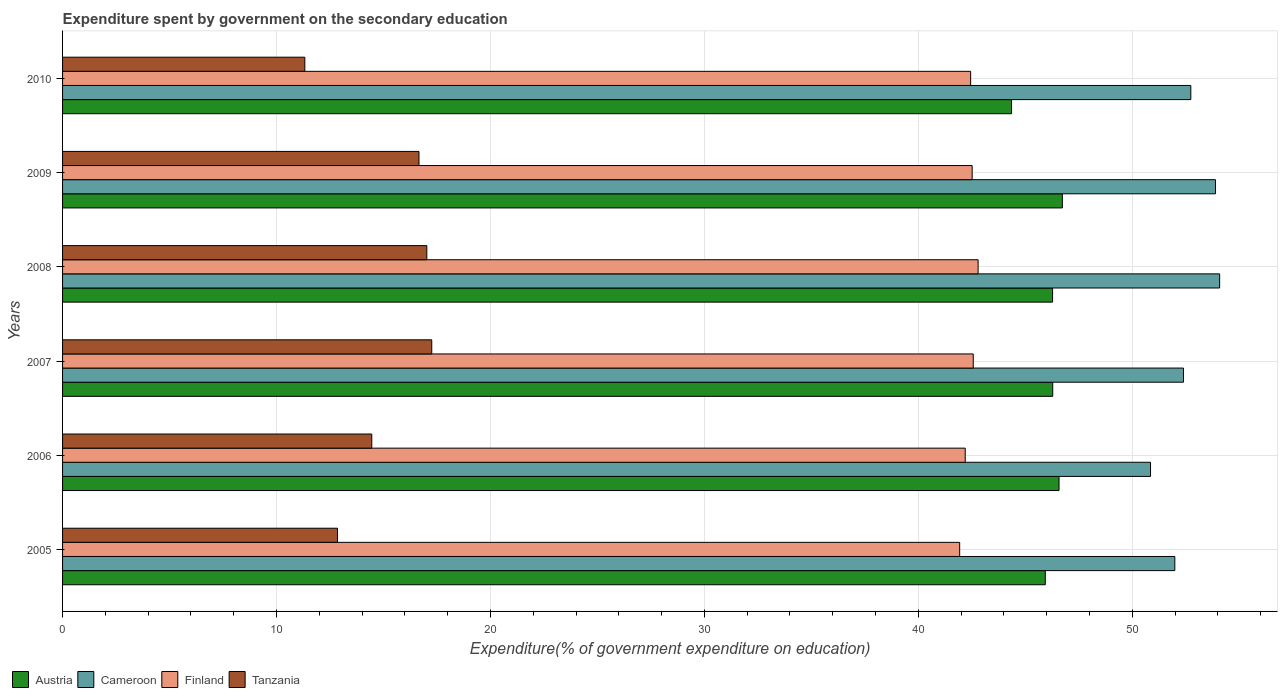How many groups of bars are there?
Give a very brief answer. 6. Are the number of bars per tick equal to the number of legend labels?
Your response must be concise. Yes. Are the number of bars on each tick of the Y-axis equal?
Give a very brief answer. Yes. How many bars are there on the 5th tick from the bottom?
Offer a terse response. 4. What is the label of the 6th group of bars from the top?
Offer a terse response. 2005. In how many cases, is the number of bars for a given year not equal to the number of legend labels?
Offer a terse response. 0. What is the expenditure spent by government on the secondary education in Finland in 2009?
Give a very brief answer. 42.52. Across all years, what is the maximum expenditure spent by government on the secondary education in Finland?
Make the answer very short. 42.8. Across all years, what is the minimum expenditure spent by government on the secondary education in Austria?
Give a very brief answer. 44.36. In which year was the expenditure spent by government on the secondary education in Finland maximum?
Offer a terse response. 2008. What is the total expenditure spent by government on the secondary education in Finland in the graph?
Ensure brevity in your answer.  254.46. What is the difference between the expenditure spent by government on the secondary education in Cameroon in 2008 and that in 2009?
Your answer should be compact. 0.19. What is the difference between the expenditure spent by government on the secondary education in Finland in 2006 and the expenditure spent by government on the secondary education in Cameroon in 2007?
Keep it short and to the point. -10.2. What is the average expenditure spent by government on the secondary education in Cameroon per year?
Make the answer very short. 52.66. In the year 2006, what is the difference between the expenditure spent by government on the secondary education in Tanzania and expenditure spent by government on the secondary education in Finland?
Your response must be concise. -27.74. What is the ratio of the expenditure spent by government on the secondary education in Cameroon in 2008 to that in 2010?
Offer a very short reply. 1.03. Is the expenditure spent by government on the secondary education in Cameroon in 2006 less than that in 2010?
Offer a very short reply. Yes. What is the difference between the highest and the second highest expenditure spent by government on the secondary education in Tanzania?
Provide a succinct answer. 0.23. What is the difference between the highest and the lowest expenditure spent by government on the secondary education in Austria?
Ensure brevity in your answer.  2.37. In how many years, is the expenditure spent by government on the secondary education in Cameroon greater than the average expenditure spent by government on the secondary education in Cameroon taken over all years?
Keep it short and to the point. 3. What does the 1st bar from the top in 2005 represents?
Ensure brevity in your answer.  Tanzania. What does the 4th bar from the bottom in 2009 represents?
Ensure brevity in your answer.  Tanzania. Are all the bars in the graph horizontal?
Make the answer very short. Yes. How many years are there in the graph?
Your answer should be very brief. 6. What is the difference between two consecutive major ticks on the X-axis?
Provide a short and direct response. 10. Does the graph contain any zero values?
Offer a very short reply. No. Does the graph contain grids?
Your response must be concise. Yes. Where does the legend appear in the graph?
Keep it short and to the point. Bottom left. How are the legend labels stacked?
Provide a succinct answer. Horizontal. What is the title of the graph?
Ensure brevity in your answer.  Expenditure spent by government on the secondary education. What is the label or title of the X-axis?
Keep it short and to the point. Expenditure(% of government expenditure on education). What is the label or title of the Y-axis?
Provide a short and direct response. Years. What is the Expenditure(% of government expenditure on education) of Austria in 2005?
Your response must be concise. 45.94. What is the Expenditure(% of government expenditure on education) of Cameroon in 2005?
Offer a very short reply. 51.99. What is the Expenditure(% of government expenditure on education) in Finland in 2005?
Offer a very short reply. 41.93. What is the Expenditure(% of government expenditure on education) of Tanzania in 2005?
Make the answer very short. 12.85. What is the Expenditure(% of government expenditure on education) in Austria in 2006?
Offer a very short reply. 46.58. What is the Expenditure(% of government expenditure on education) in Cameroon in 2006?
Give a very brief answer. 50.86. What is the Expenditure(% of government expenditure on education) in Finland in 2006?
Your answer should be compact. 42.19. What is the Expenditure(% of government expenditure on education) of Tanzania in 2006?
Offer a very short reply. 14.45. What is the Expenditure(% of government expenditure on education) of Austria in 2007?
Make the answer very short. 46.28. What is the Expenditure(% of government expenditure on education) of Cameroon in 2007?
Your answer should be very brief. 52.4. What is the Expenditure(% of government expenditure on education) of Finland in 2007?
Keep it short and to the point. 42.57. What is the Expenditure(% of government expenditure on education) in Tanzania in 2007?
Provide a short and direct response. 17.26. What is the Expenditure(% of government expenditure on education) in Austria in 2008?
Provide a short and direct response. 46.28. What is the Expenditure(% of government expenditure on education) of Cameroon in 2008?
Your answer should be very brief. 54.09. What is the Expenditure(% of government expenditure on education) in Finland in 2008?
Your answer should be compact. 42.8. What is the Expenditure(% of government expenditure on education) in Tanzania in 2008?
Your answer should be compact. 17.03. What is the Expenditure(% of government expenditure on education) of Austria in 2009?
Make the answer very short. 46.73. What is the Expenditure(% of government expenditure on education) of Cameroon in 2009?
Provide a succinct answer. 53.89. What is the Expenditure(% of government expenditure on education) of Finland in 2009?
Keep it short and to the point. 42.52. What is the Expenditure(% of government expenditure on education) of Tanzania in 2009?
Your answer should be very brief. 16.66. What is the Expenditure(% of government expenditure on education) in Austria in 2010?
Give a very brief answer. 44.36. What is the Expenditure(% of government expenditure on education) of Cameroon in 2010?
Ensure brevity in your answer.  52.74. What is the Expenditure(% of government expenditure on education) in Finland in 2010?
Keep it short and to the point. 42.45. What is the Expenditure(% of government expenditure on education) of Tanzania in 2010?
Make the answer very short. 11.32. Across all years, what is the maximum Expenditure(% of government expenditure on education) of Austria?
Your response must be concise. 46.73. Across all years, what is the maximum Expenditure(% of government expenditure on education) in Cameroon?
Your response must be concise. 54.09. Across all years, what is the maximum Expenditure(% of government expenditure on education) of Finland?
Offer a terse response. 42.8. Across all years, what is the maximum Expenditure(% of government expenditure on education) in Tanzania?
Your response must be concise. 17.26. Across all years, what is the minimum Expenditure(% of government expenditure on education) of Austria?
Your answer should be very brief. 44.36. Across all years, what is the minimum Expenditure(% of government expenditure on education) in Cameroon?
Your answer should be very brief. 50.86. Across all years, what is the minimum Expenditure(% of government expenditure on education) of Finland?
Make the answer very short. 41.93. Across all years, what is the minimum Expenditure(% of government expenditure on education) of Tanzania?
Give a very brief answer. 11.32. What is the total Expenditure(% of government expenditure on education) in Austria in the graph?
Make the answer very short. 276.17. What is the total Expenditure(% of government expenditure on education) of Cameroon in the graph?
Give a very brief answer. 315.96. What is the total Expenditure(% of government expenditure on education) in Finland in the graph?
Keep it short and to the point. 254.46. What is the total Expenditure(% of government expenditure on education) of Tanzania in the graph?
Make the answer very short. 89.57. What is the difference between the Expenditure(% of government expenditure on education) of Austria in 2005 and that in 2006?
Your answer should be compact. -0.64. What is the difference between the Expenditure(% of government expenditure on education) in Cameroon in 2005 and that in 2006?
Give a very brief answer. 1.14. What is the difference between the Expenditure(% of government expenditure on education) in Finland in 2005 and that in 2006?
Provide a succinct answer. -0.26. What is the difference between the Expenditure(% of government expenditure on education) in Tanzania in 2005 and that in 2006?
Your answer should be compact. -1.6. What is the difference between the Expenditure(% of government expenditure on education) in Austria in 2005 and that in 2007?
Offer a very short reply. -0.35. What is the difference between the Expenditure(% of government expenditure on education) of Cameroon in 2005 and that in 2007?
Your response must be concise. -0.4. What is the difference between the Expenditure(% of government expenditure on education) of Finland in 2005 and that in 2007?
Provide a succinct answer. -0.63. What is the difference between the Expenditure(% of government expenditure on education) in Tanzania in 2005 and that in 2007?
Your answer should be very brief. -4.41. What is the difference between the Expenditure(% of government expenditure on education) of Austria in 2005 and that in 2008?
Offer a very short reply. -0.34. What is the difference between the Expenditure(% of government expenditure on education) in Cameroon in 2005 and that in 2008?
Offer a very short reply. -2.09. What is the difference between the Expenditure(% of government expenditure on education) in Finland in 2005 and that in 2008?
Offer a very short reply. -0.86. What is the difference between the Expenditure(% of government expenditure on education) of Tanzania in 2005 and that in 2008?
Your response must be concise. -4.17. What is the difference between the Expenditure(% of government expenditure on education) in Austria in 2005 and that in 2009?
Make the answer very short. -0.8. What is the difference between the Expenditure(% of government expenditure on education) of Cameroon in 2005 and that in 2009?
Ensure brevity in your answer.  -1.9. What is the difference between the Expenditure(% of government expenditure on education) of Finland in 2005 and that in 2009?
Make the answer very short. -0.58. What is the difference between the Expenditure(% of government expenditure on education) of Tanzania in 2005 and that in 2009?
Provide a short and direct response. -3.81. What is the difference between the Expenditure(% of government expenditure on education) in Austria in 2005 and that in 2010?
Keep it short and to the point. 1.58. What is the difference between the Expenditure(% of government expenditure on education) in Cameroon in 2005 and that in 2010?
Ensure brevity in your answer.  -0.75. What is the difference between the Expenditure(% of government expenditure on education) of Finland in 2005 and that in 2010?
Give a very brief answer. -0.51. What is the difference between the Expenditure(% of government expenditure on education) in Tanzania in 2005 and that in 2010?
Your answer should be very brief. 1.53. What is the difference between the Expenditure(% of government expenditure on education) of Austria in 2006 and that in 2007?
Give a very brief answer. 0.29. What is the difference between the Expenditure(% of government expenditure on education) in Cameroon in 2006 and that in 2007?
Provide a short and direct response. -1.54. What is the difference between the Expenditure(% of government expenditure on education) in Finland in 2006 and that in 2007?
Keep it short and to the point. -0.38. What is the difference between the Expenditure(% of government expenditure on education) of Tanzania in 2006 and that in 2007?
Offer a very short reply. -2.8. What is the difference between the Expenditure(% of government expenditure on education) of Austria in 2006 and that in 2008?
Your response must be concise. 0.3. What is the difference between the Expenditure(% of government expenditure on education) in Cameroon in 2006 and that in 2008?
Provide a short and direct response. -3.23. What is the difference between the Expenditure(% of government expenditure on education) of Finland in 2006 and that in 2008?
Make the answer very short. -0.6. What is the difference between the Expenditure(% of government expenditure on education) of Tanzania in 2006 and that in 2008?
Provide a succinct answer. -2.57. What is the difference between the Expenditure(% of government expenditure on education) of Austria in 2006 and that in 2009?
Provide a short and direct response. -0.15. What is the difference between the Expenditure(% of government expenditure on education) in Cameroon in 2006 and that in 2009?
Make the answer very short. -3.04. What is the difference between the Expenditure(% of government expenditure on education) of Finland in 2006 and that in 2009?
Offer a terse response. -0.32. What is the difference between the Expenditure(% of government expenditure on education) of Tanzania in 2006 and that in 2009?
Give a very brief answer. -2.21. What is the difference between the Expenditure(% of government expenditure on education) in Austria in 2006 and that in 2010?
Ensure brevity in your answer.  2.22. What is the difference between the Expenditure(% of government expenditure on education) of Cameroon in 2006 and that in 2010?
Your answer should be very brief. -1.88. What is the difference between the Expenditure(% of government expenditure on education) of Finland in 2006 and that in 2010?
Your answer should be compact. -0.25. What is the difference between the Expenditure(% of government expenditure on education) in Tanzania in 2006 and that in 2010?
Provide a short and direct response. 3.13. What is the difference between the Expenditure(% of government expenditure on education) in Austria in 2007 and that in 2008?
Make the answer very short. 0.01. What is the difference between the Expenditure(% of government expenditure on education) of Cameroon in 2007 and that in 2008?
Make the answer very short. -1.69. What is the difference between the Expenditure(% of government expenditure on education) of Finland in 2007 and that in 2008?
Make the answer very short. -0.23. What is the difference between the Expenditure(% of government expenditure on education) in Tanzania in 2007 and that in 2008?
Provide a succinct answer. 0.23. What is the difference between the Expenditure(% of government expenditure on education) of Austria in 2007 and that in 2009?
Offer a very short reply. -0.45. What is the difference between the Expenditure(% of government expenditure on education) of Cameroon in 2007 and that in 2009?
Your response must be concise. -1.5. What is the difference between the Expenditure(% of government expenditure on education) in Finland in 2007 and that in 2009?
Offer a terse response. 0.05. What is the difference between the Expenditure(% of government expenditure on education) of Tanzania in 2007 and that in 2009?
Provide a succinct answer. 0.6. What is the difference between the Expenditure(% of government expenditure on education) of Austria in 2007 and that in 2010?
Your answer should be very brief. 1.92. What is the difference between the Expenditure(% of government expenditure on education) of Cameroon in 2007 and that in 2010?
Make the answer very short. -0.34. What is the difference between the Expenditure(% of government expenditure on education) of Finland in 2007 and that in 2010?
Keep it short and to the point. 0.12. What is the difference between the Expenditure(% of government expenditure on education) in Tanzania in 2007 and that in 2010?
Provide a succinct answer. 5.93. What is the difference between the Expenditure(% of government expenditure on education) of Austria in 2008 and that in 2009?
Give a very brief answer. -0.46. What is the difference between the Expenditure(% of government expenditure on education) in Cameroon in 2008 and that in 2009?
Give a very brief answer. 0.19. What is the difference between the Expenditure(% of government expenditure on education) of Finland in 2008 and that in 2009?
Provide a short and direct response. 0.28. What is the difference between the Expenditure(% of government expenditure on education) of Tanzania in 2008 and that in 2009?
Offer a very short reply. 0.37. What is the difference between the Expenditure(% of government expenditure on education) in Austria in 2008 and that in 2010?
Keep it short and to the point. 1.92. What is the difference between the Expenditure(% of government expenditure on education) of Cameroon in 2008 and that in 2010?
Your response must be concise. 1.35. What is the difference between the Expenditure(% of government expenditure on education) of Finland in 2008 and that in 2010?
Offer a very short reply. 0.35. What is the difference between the Expenditure(% of government expenditure on education) in Tanzania in 2008 and that in 2010?
Your answer should be compact. 5.7. What is the difference between the Expenditure(% of government expenditure on education) of Austria in 2009 and that in 2010?
Provide a short and direct response. 2.37. What is the difference between the Expenditure(% of government expenditure on education) in Cameroon in 2009 and that in 2010?
Make the answer very short. 1.15. What is the difference between the Expenditure(% of government expenditure on education) in Finland in 2009 and that in 2010?
Your response must be concise. 0.07. What is the difference between the Expenditure(% of government expenditure on education) in Tanzania in 2009 and that in 2010?
Offer a terse response. 5.34. What is the difference between the Expenditure(% of government expenditure on education) of Austria in 2005 and the Expenditure(% of government expenditure on education) of Cameroon in 2006?
Your answer should be compact. -4.92. What is the difference between the Expenditure(% of government expenditure on education) in Austria in 2005 and the Expenditure(% of government expenditure on education) in Finland in 2006?
Keep it short and to the point. 3.74. What is the difference between the Expenditure(% of government expenditure on education) of Austria in 2005 and the Expenditure(% of government expenditure on education) of Tanzania in 2006?
Provide a succinct answer. 31.48. What is the difference between the Expenditure(% of government expenditure on education) in Cameroon in 2005 and the Expenditure(% of government expenditure on education) in Finland in 2006?
Ensure brevity in your answer.  9.8. What is the difference between the Expenditure(% of government expenditure on education) of Cameroon in 2005 and the Expenditure(% of government expenditure on education) of Tanzania in 2006?
Ensure brevity in your answer.  37.54. What is the difference between the Expenditure(% of government expenditure on education) of Finland in 2005 and the Expenditure(% of government expenditure on education) of Tanzania in 2006?
Ensure brevity in your answer.  27.48. What is the difference between the Expenditure(% of government expenditure on education) in Austria in 2005 and the Expenditure(% of government expenditure on education) in Cameroon in 2007?
Keep it short and to the point. -6.46. What is the difference between the Expenditure(% of government expenditure on education) in Austria in 2005 and the Expenditure(% of government expenditure on education) in Finland in 2007?
Offer a very short reply. 3.37. What is the difference between the Expenditure(% of government expenditure on education) of Austria in 2005 and the Expenditure(% of government expenditure on education) of Tanzania in 2007?
Offer a very short reply. 28.68. What is the difference between the Expenditure(% of government expenditure on education) of Cameroon in 2005 and the Expenditure(% of government expenditure on education) of Finland in 2007?
Offer a very short reply. 9.42. What is the difference between the Expenditure(% of government expenditure on education) of Cameroon in 2005 and the Expenditure(% of government expenditure on education) of Tanzania in 2007?
Keep it short and to the point. 34.74. What is the difference between the Expenditure(% of government expenditure on education) in Finland in 2005 and the Expenditure(% of government expenditure on education) in Tanzania in 2007?
Provide a short and direct response. 24.68. What is the difference between the Expenditure(% of government expenditure on education) in Austria in 2005 and the Expenditure(% of government expenditure on education) in Cameroon in 2008?
Your answer should be compact. -8.15. What is the difference between the Expenditure(% of government expenditure on education) in Austria in 2005 and the Expenditure(% of government expenditure on education) in Finland in 2008?
Ensure brevity in your answer.  3.14. What is the difference between the Expenditure(% of government expenditure on education) of Austria in 2005 and the Expenditure(% of government expenditure on education) of Tanzania in 2008?
Your answer should be very brief. 28.91. What is the difference between the Expenditure(% of government expenditure on education) of Cameroon in 2005 and the Expenditure(% of government expenditure on education) of Finland in 2008?
Keep it short and to the point. 9.2. What is the difference between the Expenditure(% of government expenditure on education) in Cameroon in 2005 and the Expenditure(% of government expenditure on education) in Tanzania in 2008?
Offer a very short reply. 34.97. What is the difference between the Expenditure(% of government expenditure on education) of Finland in 2005 and the Expenditure(% of government expenditure on education) of Tanzania in 2008?
Provide a succinct answer. 24.91. What is the difference between the Expenditure(% of government expenditure on education) in Austria in 2005 and the Expenditure(% of government expenditure on education) in Cameroon in 2009?
Provide a succinct answer. -7.95. What is the difference between the Expenditure(% of government expenditure on education) in Austria in 2005 and the Expenditure(% of government expenditure on education) in Finland in 2009?
Ensure brevity in your answer.  3.42. What is the difference between the Expenditure(% of government expenditure on education) in Austria in 2005 and the Expenditure(% of government expenditure on education) in Tanzania in 2009?
Keep it short and to the point. 29.28. What is the difference between the Expenditure(% of government expenditure on education) in Cameroon in 2005 and the Expenditure(% of government expenditure on education) in Finland in 2009?
Your answer should be very brief. 9.47. What is the difference between the Expenditure(% of government expenditure on education) of Cameroon in 2005 and the Expenditure(% of government expenditure on education) of Tanzania in 2009?
Make the answer very short. 35.33. What is the difference between the Expenditure(% of government expenditure on education) of Finland in 2005 and the Expenditure(% of government expenditure on education) of Tanzania in 2009?
Provide a succinct answer. 25.27. What is the difference between the Expenditure(% of government expenditure on education) of Austria in 2005 and the Expenditure(% of government expenditure on education) of Cameroon in 2010?
Your answer should be compact. -6.8. What is the difference between the Expenditure(% of government expenditure on education) of Austria in 2005 and the Expenditure(% of government expenditure on education) of Finland in 2010?
Your answer should be very brief. 3.49. What is the difference between the Expenditure(% of government expenditure on education) of Austria in 2005 and the Expenditure(% of government expenditure on education) of Tanzania in 2010?
Offer a very short reply. 34.61. What is the difference between the Expenditure(% of government expenditure on education) in Cameroon in 2005 and the Expenditure(% of government expenditure on education) in Finland in 2010?
Your answer should be very brief. 9.54. What is the difference between the Expenditure(% of government expenditure on education) of Cameroon in 2005 and the Expenditure(% of government expenditure on education) of Tanzania in 2010?
Provide a short and direct response. 40.67. What is the difference between the Expenditure(% of government expenditure on education) in Finland in 2005 and the Expenditure(% of government expenditure on education) in Tanzania in 2010?
Offer a terse response. 30.61. What is the difference between the Expenditure(% of government expenditure on education) in Austria in 2006 and the Expenditure(% of government expenditure on education) in Cameroon in 2007?
Provide a short and direct response. -5.82. What is the difference between the Expenditure(% of government expenditure on education) of Austria in 2006 and the Expenditure(% of government expenditure on education) of Finland in 2007?
Make the answer very short. 4.01. What is the difference between the Expenditure(% of government expenditure on education) of Austria in 2006 and the Expenditure(% of government expenditure on education) of Tanzania in 2007?
Ensure brevity in your answer.  29.32. What is the difference between the Expenditure(% of government expenditure on education) in Cameroon in 2006 and the Expenditure(% of government expenditure on education) in Finland in 2007?
Ensure brevity in your answer.  8.29. What is the difference between the Expenditure(% of government expenditure on education) in Cameroon in 2006 and the Expenditure(% of government expenditure on education) in Tanzania in 2007?
Offer a terse response. 33.6. What is the difference between the Expenditure(% of government expenditure on education) in Finland in 2006 and the Expenditure(% of government expenditure on education) in Tanzania in 2007?
Offer a terse response. 24.94. What is the difference between the Expenditure(% of government expenditure on education) of Austria in 2006 and the Expenditure(% of government expenditure on education) of Cameroon in 2008?
Offer a very short reply. -7.51. What is the difference between the Expenditure(% of government expenditure on education) in Austria in 2006 and the Expenditure(% of government expenditure on education) in Finland in 2008?
Give a very brief answer. 3.78. What is the difference between the Expenditure(% of government expenditure on education) of Austria in 2006 and the Expenditure(% of government expenditure on education) of Tanzania in 2008?
Provide a short and direct response. 29.55. What is the difference between the Expenditure(% of government expenditure on education) of Cameroon in 2006 and the Expenditure(% of government expenditure on education) of Finland in 2008?
Offer a terse response. 8.06. What is the difference between the Expenditure(% of government expenditure on education) in Cameroon in 2006 and the Expenditure(% of government expenditure on education) in Tanzania in 2008?
Keep it short and to the point. 33.83. What is the difference between the Expenditure(% of government expenditure on education) of Finland in 2006 and the Expenditure(% of government expenditure on education) of Tanzania in 2008?
Your answer should be very brief. 25.17. What is the difference between the Expenditure(% of government expenditure on education) of Austria in 2006 and the Expenditure(% of government expenditure on education) of Cameroon in 2009?
Keep it short and to the point. -7.31. What is the difference between the Expenditure(% of government expenditure on education) of Austria in 2006 and the Expenditure(% of government expenditure on education) of Finland in 2009?
Give a very brief answer. 4.06. What is the difference between the Expenditure(% of government expenditure on education) of Austria in 2006 and the Expenditure(% of government expenditure on education) of Tanzania in 2009?
Your answer should be very brief. 29.92. What is the difference between the Expenditure(% of government expenditure on education) in Cameroon in 2006 and the Expenditure(% of government expenditure on education) in Finland in 2009?
Your answer should be very brief. 8.34. What is the difference between the Expenditure(% of government expenditure on education) of Cameroon in 2006 and the Expenditure(% of government expenditure on education) of Tanzania in 2009?
Provide a short and direct response. 34.2. What is the difference between the Expenditure(% of government expenditure on education) of Finland in 2006 and the Expenditure(% of government expenditure on education) of Tanzania in 2009?
Make the answer very short. 25.53. What is the difference between the Expenditure(% of government expenditure on education) in Austria in 2006 and the Expenditure(% of government expenditure on education) in Cameroon in 2010?
Offer a very short reply. -6.16. What is the difference between the Expenditure(% of government expenditure on education) in Austria in 2006 and the Expenditure(% of government expenditure on education) in Finland in 2010?
Your answer should be compact. 4.13. What is the difference between the Expenditure(% of government expenditure on education) of Austria in 2006 and the Expenditure(% of government expenditure on education) of Tanzania in 2010?
Offer a very short reply. 35.26. What is the difference between the Expenditure(% of government expenditure on education) in Cameroon in 2006 and the Expenditure(% of government expenditure on education) in Finland in 2010?
Offer a terse response. 8.41. What is the difference between the Expenditure(% of government expenditure on education) of Cameroon in 2006 and the Expenditure(% of government expenditure on education) of Tanzania in 2010?
Provide a succinct answer. 39.53. What is the difference between the Expenditure(% of government expenditure on education) of Finland in 2006 and the Expenditure(% of government expenditure on education) of Tanzania in 2010?
Offer a terse response. 30.87. What is the difference between the Expenditure(% of government expenditure on education) of Austria in 2007 and the Expenditure(% of government expenditure on education) of Cameroon in 2008?
Give a very brief answer. -7.8. What is the difference between the Expenditure(% of government expenditure on education) of Austria in 2007 and the Expenditure(% of government expenditure on education) of Finland in 2008?
Provide a short and direct response. 3.49. What is the difference between the Expenditure(% of government expenditure on education) of Austria in 2007 and the Expenditure(% of government expenditure on education) of Tanzania in 2008?
Your answer should be compact. 29.26. What is the difference between the Expenditure(% of government expenditure on education) in Cameroon in 2007 and the Expenditure(% of government expenditure on education) in Finland in 2008?
Offer a terse response. 9.6. What is the difference between the Expenditure(% of government expenditure on education) in Cameroon in 2007 and the Expenditure(% of government expenditure on education) in Tanzania in 2008?
Make the answer very short. 35.37. What is the difference between the Expenditure(% of government expenditure on education) in Finland in 2007 and the Expenditure(% of government expenditure on education) in Tanzania in 2008?
Offer a terse response. 25.54. What is the difference between the Expenditure(% of government expenditure on education) of Austria in 2007 and the Expenditure(% of government expenditure on education) of Cameroon in 2009?
Offer a terse response. -7.61. What is the difference between the Expenditure(% of government expenditure on education) in Austria in 2007 and the Expenditure(% of government expenditure on education) in Finland in 2009?
Your answer should be compact. 3.77. What is the difference between the Expenditure(% of government expenditure on education) in Austria in 2007 and the Expenditure(% of government expenditure on education) in Tanzania in 2009?
Your answer should be compact. 29.62. What is the difference between the Expenditure(% of government expenditure on education) in Cameroon in 2007 and the Expenditure(% of government expenditure on education) in Finland in 2009?
Offer a very short reply. 9.88. What is the difference between the Expenditure(% of government expenditure on education) of Cameroon in 2007 and the Expenditure(% of government expenditure on education) of Tanzania in 2009?
Make the answer very short. 35.73. What is the difference between the Expenditure(% of government expenditure on education) in Finland in 2007 and the Expenditure(% of government expenditure on education) in Tanzania in 2009?
Offer a terse response. 25.91. What is the difference between the Expenditure(% of government expenditure on education) in Austria in 2007 and the Expenditure(% of government expenditure on education) in Cameroon in 2010?
Keep it short and to the point. -6.45. What is the difference between the Expenditure(% of government expenditure on education) in Austria in 2007 and the Expenditure(% of government expenditure on education) in Finland in 2010?
Provide a succinct answer. 3.84. What is the difference between the Expenditure(% of government expenditure on education) of Austria in 2007 and the Expenditure(% of government expenditure on education) of Tanzania in 2010?
Your response must be concise. 34.96. What is the difference between the Expenditure(% of government expenditure on education) in Cameroon in 2007 and the Expenditure(% of government expenditure on education) in Finland in 2010?
Provide a succinct answer. 9.95. What is the difference between the Expenditure(% of government expenditure on education) in Cameroon in 2007 and the Expenditure(% of government expenditure on education) in Tanzania in 2010?
Ensure brevity in your answer.  41.07. What is the difference between the Expenditure(% of government expenditure on education) in Finland in 2007 and the Expenditure(% of government expenditure on education) in Tanzania in 2010?
Make the answer very short. 31.24. What is the difference between the Expenditure(% of government expenditure on education) in Austria in 2008 and the Expenditure(% of government expenditure on education) in Cameroon in 2009?
Give a very brief answer. -7.61. What is the difference between the Expenditure(% of government expenditure on education) of Austria in 2008 and the Expenditure(% of government expenditure on education) of Finland in 2009?
Give a very brief answer. 3.76. What is the difference between the Expenditure(% of government expenditure on education) in Austria in 2008 and the Expenditure(% of government expenditure on education) in Tanzania in 2009?
Provide a succinct answer. 29.62. What is the difference between the Expenditure(% of government expenditure on education) of Cameroon in 2008 and the Expenditure(% of government expenditure on education) of Finland in 2009?
Make the answer very short. 11.57. What is the difference between the Expenditure(% of government expenditure on education) of Cameroon in 2008 and the Expenditure(% of government expenditure on education) of Tanzania in 2009?
Make the answer very short. 37.43. What is the difference between the Expenditure(% of government expenditure on education) of Finland in 2008 and the Expenditure(% of government expenditure on education) of Tanzania in 2009?
Ensure brevity in your answer.  26.14. What is the difference between the Expenditure(% of government expenditure on education) in Austria in 2008 and the Expenditure(% of government expenditure on education) in Cameroon in 2010?
Make the answer very short. -6.46. What is the difference between the Expenditure(% of government expenditure on education) in Austria in 2008 and the Expenditure(% of government expenditure on education) in Finland in 2010?
Provide a succinct answer. 3.83. What is the difference between the Expenditure(% of government expenditure on education) of Austria in 2008 and the Expenditure(% of government expenditure on education) of Tanzania in 2010?
Keep it short and to the point. 34.95. What is the difference between the Expenditure(% of government expenditure on education) of Cameroon in 2008 and the Expenditure(% of government expenditure on education) of Finland in 2010?
Provide a short and direct response. 11.64. What is the difference between the Expenditure(% of government expenditure on education) of Cameroon in 2008 and the Expenditure(% of government expenditure on education) of Tanzania in 2010?
Offer a very short reply. 42.76. What is the difference between the Expenditure(% of government expenditure on education) in Finland in 2008 and the Expenditure(% of government expenditure on education) in Tanzania in 2010?
Your answer should be very brief. 31.47. What is the difference between the Expenditure(% of government expenditure on education) of Austria in 2009 and the Expenditure(% of government expenditure on education) of Cameroon in 2010?
Make the answer very short. -6.01. What is the difference between the Expenditure(% of government expenditure on education) in Austria in 2009 and the Expenditure(% of government expenditure on education) in Finland in 2010?
Your answer should be compact. 4.29. What is the difference between the Expenditure(% of government expenditure on education) in Austria in 2009 and the Expenditure(% of government expenditure on education) in Tanzania in 2010?
Offer a very short reply. 35.41. What is the difference between the Expenditure(% of government expenditure on education) of Cameroon in 2009 and the Expenditure(% of government expenditure on education) of Finland in 2010?
Ensure brevity in your answer.  11.44. What is the difference between the Expenditure(% of government expenditure on education) in Cameroon in 2009 and the Expenditure(% of government expenditure on education) in Tanzania in 2010?
Provide a succinct answer. 42.57. What is the difference between the Expenditure(% of government expenditure on education) in Finland in 2009 and the Expenditure(% of government expenditure on education) in Tanzania in 2010?
Keep it short and to the point. 31.19. What is the average Expenditure(% of government expenditure on education) of Austria per year?
Give a very brief answer. 46.03. What is the average Expenditure(% of government expenditure on education) in Cameroon per year?
Your response must be concise. 52.66. What is the average Expenditure(% of government expenditure on education) in Finland per year?
Keep it short and to the point. 42.41. What is the average Expenditure(% of government expenditure on education) in Tanzania per year?
Your answer should be very brief. 14.93. In the year 2005, what is the difference between the Expenditure(% of government expenditure on education) of Austria and Expenditure(% of government expenditure on education) of Cameroon?
Provide a short and direct response. -6.05. In the year 2005, what is the difference between the Expenditure(% of government expenditure on education) in Austria and Expenditure(% of government expenditure on education) in Finland?
Give a very brief answer. 4. In the year 2005, what is the difference between the Expenditure(% of government expenditure on education) in Austria and Expenditure(% of government expenditure on education) in Tanzania?
Keep it short and to the point. 33.09. In the year 2005, what is the difference between the Expenditure(% of government expenditure on education) in Cameroon and Expenditure(% of government expenditure on education) in Finland?
Offer a terse response. 10.06. In the year 2005, what is the difference between the Expenditure(% of government expenditure on education) in Cameroon and Expenditure(% of government expenditure on education) in Tanzania?
Your response must be concise. 39.14. In the year 2005, what is the difference between the Expenditure(% of government expenditure on education) in Finland and Expenditure(% of government expenditure on education) in Tanzania?
Provide a short and direct response. 29.08. In the year 2006, what is the difference between the Expenditure(% of government expenditure on education) of Austria and Expenditure(% of government expenditure on education) of Cameroon?
Your response must be concise. -4.28. In the year 2006, what is the difference between the Expenditure(% of government expenditure on education) of Austria and Expenditure(% of government expenditure on education) of Finland?
Make the answer very short. 4.39. In the year 2006, what is the difference between the Expenditure(% of government expenditure on education) of Austria and Expenditure(% of government expenditure on education) of Tanzania?
Provide a succinct answer. 32.13. In the year 2006, what is the difference between the Expenditure(% of government expenditure on education) of Cameroon and Expenditure(% of government expenditure on education) of Finland?
Provide a short and direct response. 8.66. In the year 2006, what is the difference between the Expenditure(% of government expenditure on education) of Cameroon and Expenditure(% of government expenditure on education) of Tanzania?
Offer a terse response. 36.4. In the year 2006, what is the difference between the Expenditure(% of government expenditure on education) in Finland and Expenditure(% of government expenditure on education) in Tanzania?
Offer a terse response. 27.74. In the year 2007, what is the difference between the Expenditure(% of government expenditure on education) of Austria and Expenditure(% of government expenditure on education) of Cameroon?
Give a very brief answer. -6.11. In the year 2007, what is the difference between the Expenditure(% of government expenditure on education) of Austria and Expenditure(% of government expenditure on education) of Finland?
Your response must be concise. 3.72. In the year 2007, what is the difference between the Expenditure(% of government expenditure on education) in Austria and Expenditure(% of government expenditure on education) in Tanzania?
Your answer should be very brief. 29.03. In the year 2007, what is the difference between the Expenditure(% of government expenditure on education) in Cameroon and Expenditure(% of government expenditure on education) in Finland?
Make the answer very short. 9.83. In the year 2007, what is the difference between the Expenditure(% of government expenditure on education) in Cameroon and Expenditure(% of government expenditure on education) in Tanzania?
Ensure brevity in your answer.  35.14. In the year 2007, what is the difference between the Expenditure(% of government expenditure on education) in Finland and Expenditure(% of government expenditure on education) in Tanzania?
Your answer should be very brief. 25.31. In the year 2008, what is the difference between the Expenditure(% of government expenditure on education) of Austria and Expenditure(% of government expenditure on education) of Cameroon?
Offer a terse response. -7.81. In the year 2008, what is the difference between the Expenditure(% of government expenditure on education) in Austria and Expenditure(% of government expenditure on education) in Finland?
Offer a terse response. 3.48. In the year 2008, what is the difference between the Expenditure(% of government expenditure on education) in Austria and Expenditure(% of government expenditure on education) in Tanzania?
Give a very brief answer. 29.25. In the year 2008, what is the difference between the Expenditure(% of government expenditure on education) in Cameroon and Expenditure(% of government expenditure on education) in Finland?
Your response must be concise. 11.29. In the year 2008, what is the difference between the Expenditure(% of government expenditure on education) in Cameroon and Expenditure(% of government expenditure on education) in Tanzania?
Your response must be concise. 37.06. In the year 2008, what is the difference between the Expenditure(% of government expenditure on education) of Finland and Expenditure(% of government expenditure on education) of Tanzania?
Your response must be concise. 25.77. In the year 2009, what is the difference between the Expenditure(% of government expenditure on education) of Austria and Expenditure(% of government expenditure on education) of Cameroon?
Keep it short and to the point. -7.16. In the year 2009, what is the difference between the Expenditure(% of government expenditure on education) in Austria and Expenditure(% of government expenditure on education) in Finland?
Give a very brief answer. 4.22. In the year 2009, what is the difference between the Expenditure(% of government expenditure on education) in Austria and Expenditure(% of government expenditure on education) in Tanzania?
Give a very brief answer. 30.07. In the year 2009, what is the difference between the Expenditure(% of government expenditure on education) of Cameroon and Expenditure(% of government expenditure on education) of Finland?
Offer a very short reply. 11.37. In the year 2009, what is the difference between the Expenditure(% of government expenditure on education) of Cameroon and Expenditure(% of government expenditure on education) of Tanzania?
Offer a terse response. 37.23. In the year 2009, what is the difference between the Expenditure(% of government expenditure on education) in Finland and Expenditure(% of government expenditure on education) in Tanzania?
Offer a terse response. 25.86. In the year 2010, what is the difference between the Expenditure(% of government expenditure on education) of Austria and Expenditure(% of government expenditure on education) of Cameroon?
Make the answer very short. -8.38. In the year 2010, what is the difference between the Expenditure(% of government expenditure on education) in Austria and Expenditure(% of government expenditure on education) in Finland?
Offer a very short reply. 1.91. In the year 2010, what is the difference between the Expenditure(% of government expenditure on education) of Austria and Expenditure(% of government expenditure on education) of Tanzania?
Provide a succinct answer. 33.04. In the year 2010, what is the difference between the Expenditure(% of government expenditure on education) of Cameroon and Expenditure(% of government expenditure on education) of Finland?
Ensure brevity in your answer.  10.29. In the year 2010, what is the difference between the Expenditure(% of government expenditure on education) in Cameroon and Expenditure(% of government expenditure on education) in Tanzania?
Offer a terse response. 41.41. In the year 2010, what is the difference between the Expenditure(% of government expenditure on education) in Finland and Expenditure(% of government expenditure on education) in Tanzania?
Make the answer very short. 31.12. What is the ratio of the Expenditure(% of government expenditure on education) in Austria in 2005 to that in 2006?
Give a very brief answer. 0.99. What is the ratio of the Expenditure(% of government expenditure on education) of Cameroon in 2005 to that in 2006?
Provide a short and direct response. 1.02. What is the ratio of the Expenditure(% of government expenditure on education) of Finland in 2005 to that in 2006?
Give a very brief answer. 0.99. What is the ratio of the Expenditure(% of government expenditure on education) of Tanzania in 2005 to that in 2006?
Make the answer very short. 0.89. What is the ratio of the Expenditure(% of government expenditure on education) of Austria in 2005 to that in 2007?
Offer a very short reply. 0.99. What is the ratio of the Expenditure(% of government expenditure on education) in Cameroon in 2005 to that in 2007?
Provide a short and direct response. 0.99. What is the ratio of the Expenditure(% of government expenditure on education) in Finland in 2005 to that in 2007?
Keep it short and to the point. 0.99. What is the ratio of the Expenditure(% of government expenditure on education) of Tanzania in 2005 to that in 2007?
Ensure brevity in your answer.  0.74. What is the ratio of the Expenditure(% of government expenditure on education) in Austria in 2005 to that in 2008?
Your answer should be very brief. 0.99. What is the ratio of the Expenditure(% of government expenditure on education) of Cameroon in 2005 to that in 2008?
Ensure brevity in your answer.  0.96. What is the ratio of the Expenditure(% of government expenditure on education) of Finland in 2005 to that in 2008?
Provide a succinct answer. 0.98. What is the ratio of the Expenditure(% of government expenditure on education) in Tanzania in 2005 to that in 2008?
Ensure brevity in your answer.  0.75. What is the ratio of the Expenditure(% of government expenditure on education) in Austria in 2005 to that in 2009?
Make the answer very short. 0.98. What is the ratio of the Expenditure(% of government expenditure on education) of Cameroon in 2005 to that in 2009?
Offer a terse response. 0.96. What is the ratio of the Expenditure(% of government expenditure on education) of Finland in 2005 to that in 2009?
Make the answer very short. 0.99. What is the ratio of the Expenditure(% of government expenditure on education) in Tanzania in 2005 to that in 2009?
Your answer should be very brief. 0.77. What is the ratio of the Expenditure(% of government expenditure on education) in Austria in 2005 to that in 2010?
Offer a very short reply. 1.04. What is the ratio of the Expenditure(% of government expenditure on education) of Cameroon in 2005 to that in 2010?
Keep it short and to the point. 0.99. What is the ratio of the Expenditure(% of government expenditure on education) of Finland in 2005 to that in 2010?
Offer a very short reply. 0.99. What is the ratio of the Expenditure(% of government expenditure on education) in Tanzania in 2005 to that in 2010?
Give a very brief answer. 1.13. What is the ratio of the Expenditure(% of government expenditure on education) of Austria in 2006 to that in 2007?
Ensure brevity in your answer.  1.01. What is the ratio of the Expenditure(% of government expenditure on education) in Cameroon in 2006 to that in 2007?
Provide a short and direct response. 0.97. What is the ratio of the Expenditure(% of government expenditure on education) in Finland in 2006 to that in 2007?
Give a very brief answer. 0.99. What is the ratio of the Expenditure(% of government expenditure on education) of Tanzania in 2006 to that in 2007?
Provide a short and direct response. 0.84. What is the ratio of the Expenditure(% of government expenditure on education) in Cameroon in 2006 to that in 2008?
Provide a succinct answer. 0.94. What is the ratio of the Expenditure(% of government expenditure on education) in Finland in 2006 to that in 2008?
Make the answer very short. 0.99. What is the ratio of the Expenditure(% of government expenditure on education) of Tanzania in 2006 to that in 2008?
Your answer should be very brief. 0.85. What is the ratio of the Expenditure(% of government expenditure on education) in Cameroon in 2006 to that in 2009?
Provide a short and direct response. 0.94. What is the ratio of the Expenditure(% of government expenditure on education) in Tanzania in 2006 to that in 2009?
Your answer should be very brief. 0.87. What is the ratio of the Expenditure(% of government expenditure on education) in Austria in 2006 to that in 2010?
Offer a very short reply. 1.05. What is the ratio of the Expenditure(% of government expenditure on education) in Cameroon in 2006 to that in 2010?
Keep it short and to the point. 0.96. What is the ratio of the Expenditure(% of government expenditure on education) in Finland in 2006 to that in 2010?
Ensure brevity in your answer.  0.99. What is the ratio of the Expenditure(% of government expenditure on education) in Tanzania in 2006 to that in 2010?
Ensure brevity in your answer.  1.28. What is the ratio of the Expenditure(% of government expenditure on education) in Austria in 2007 to that in 2008?
Offer a very short reply. 1. What is the ratio of the Expenditure(% of government expenditure on education) in Cameroon in 2007 to that in 2008?
Your answer should be compact. 0.97. What is the ratio of the Expenditure(% of government expenditure on education) in Tanzania in 2007 to that in 2008?
Provide a short and direct response. 1.01. What is the ratio of the Expenditure(% of government expenditure on education) in Austria in 2007 to that in 2009?
Your answer should be very brief. 0.99. What is the ratio of the Expenditure(% of government expenditure on education) of Cameroon in 2007 to that in 2009?
Offer a terse response. 0.97. What is the ratio of the Expenditure(% of government expenditure on education) in Finland in 2007 to that in 2009?
Offer a very short reply. 1. What is the ratio of the Expenditure(% of government expenditure on education) in Tanzania in 2007 to that in 2009?
Your answer should be very brief. 1.04. What is the ratio of the Expenditure(% of government expenditure on education) in Austria in 2007 to that in 2010?
Your answer should be very brief. 1.04. What is the ratio of the Expenditure(% of government expenditure on education) of Finland in 2007 to that in 2010?
Your answer should be compact. 1. What is the ratio of the Expenditure(% of government expenditure on education) in Tanzania in 2007 to that in 2010?
Make the answer very short. 1.52. What is the ratio of the Expenditure(% of government expenditure on education) of Austria in 2008 to that in 2009?
Make the answer very short. 0.99. What is the ratio of the Expenditure(% of government expenditure on education) in Cameroon in 2008 to that in 2009?
Keep it short and to the point. 1. What is the ratio of the Expenditure(% of government expenditure on education) of Finland in 2008 to that in 2009?
Provide a succinct answer. 1.01. What is the ratio of the Expenditure(% of government expenditure on education) of Tanzania in 2008 to that in 2009?
Your answer should be very brief. 1.02. What is the ratio of the Expenditure(% of government expenditure on education) in Austria in 2008 to that in 2010?
Offer a terse response. 1.04. What is the ratio of the Expenditure(% of government expenditure on education) in Cameroon in 2008 to that in 2010?
Provide a short and direct response. 1.03. What is the ratio of the Expenditure(% of government expenditure on education) of Finland in 2008 to that in 2010?
Offer a terse response. 1.01. What is the ratio of the Expenditure(% of government expenditure on education) of Tanzania in 2008 to that in 2010?
Ensure brevity in your answer.  1.5. What is the ratio of the Expenditure(% of government expenditure on education) of Austria in 2009 to that in 2010?
Provide a succinct answer. 1.05. What is the ratio of the Expenditure(% of government expenditure on education) of Cameroon in 2009 to that in 2010?
Your response must be concise. 1.02. What is the ratio of the Expenditure(% of government expenditure on education) in Tanzania in 2009 to that in 2010?
Offer a terse response. 1.47. What is the difference between the highest and the second highest Expenditure(% of government expenditure on education) of Austria?
Make the answer very short. 0.15. What is the difference between the highest and the second highest Expenditure(% of government expenditure on education) in Cameroon?
Your answer should be compact. 0.19. What is the difference between the highest and the second highest Expenditure(% of government expenditure on education) in Finland?
Make the answer very short. 0.23. What is the difference between the highest and the second highest Expenditure(% of government expenditure on education) of Tanzania?
Keep it short and to the point. 0.23. What is the difference between the highest and the lowest Expenditure(% of government expenditure on education) in Austria?
Offer a very short reply. 2.37. What is the difference between the highest and the lowest Expenditure(% of government expenditure on education) in Cameroon?
Provide a succinct answer. 3.23. What is the difference between the highest and the lowest Expenditure(% of government expenditure on education) of Finland?
Ensure brevity in your answer.  0.86. What is the difference between the highest and the lowest Expenditure(% of government expenditure on education) in Tanzania?
Make the answer very short. 5.93. 